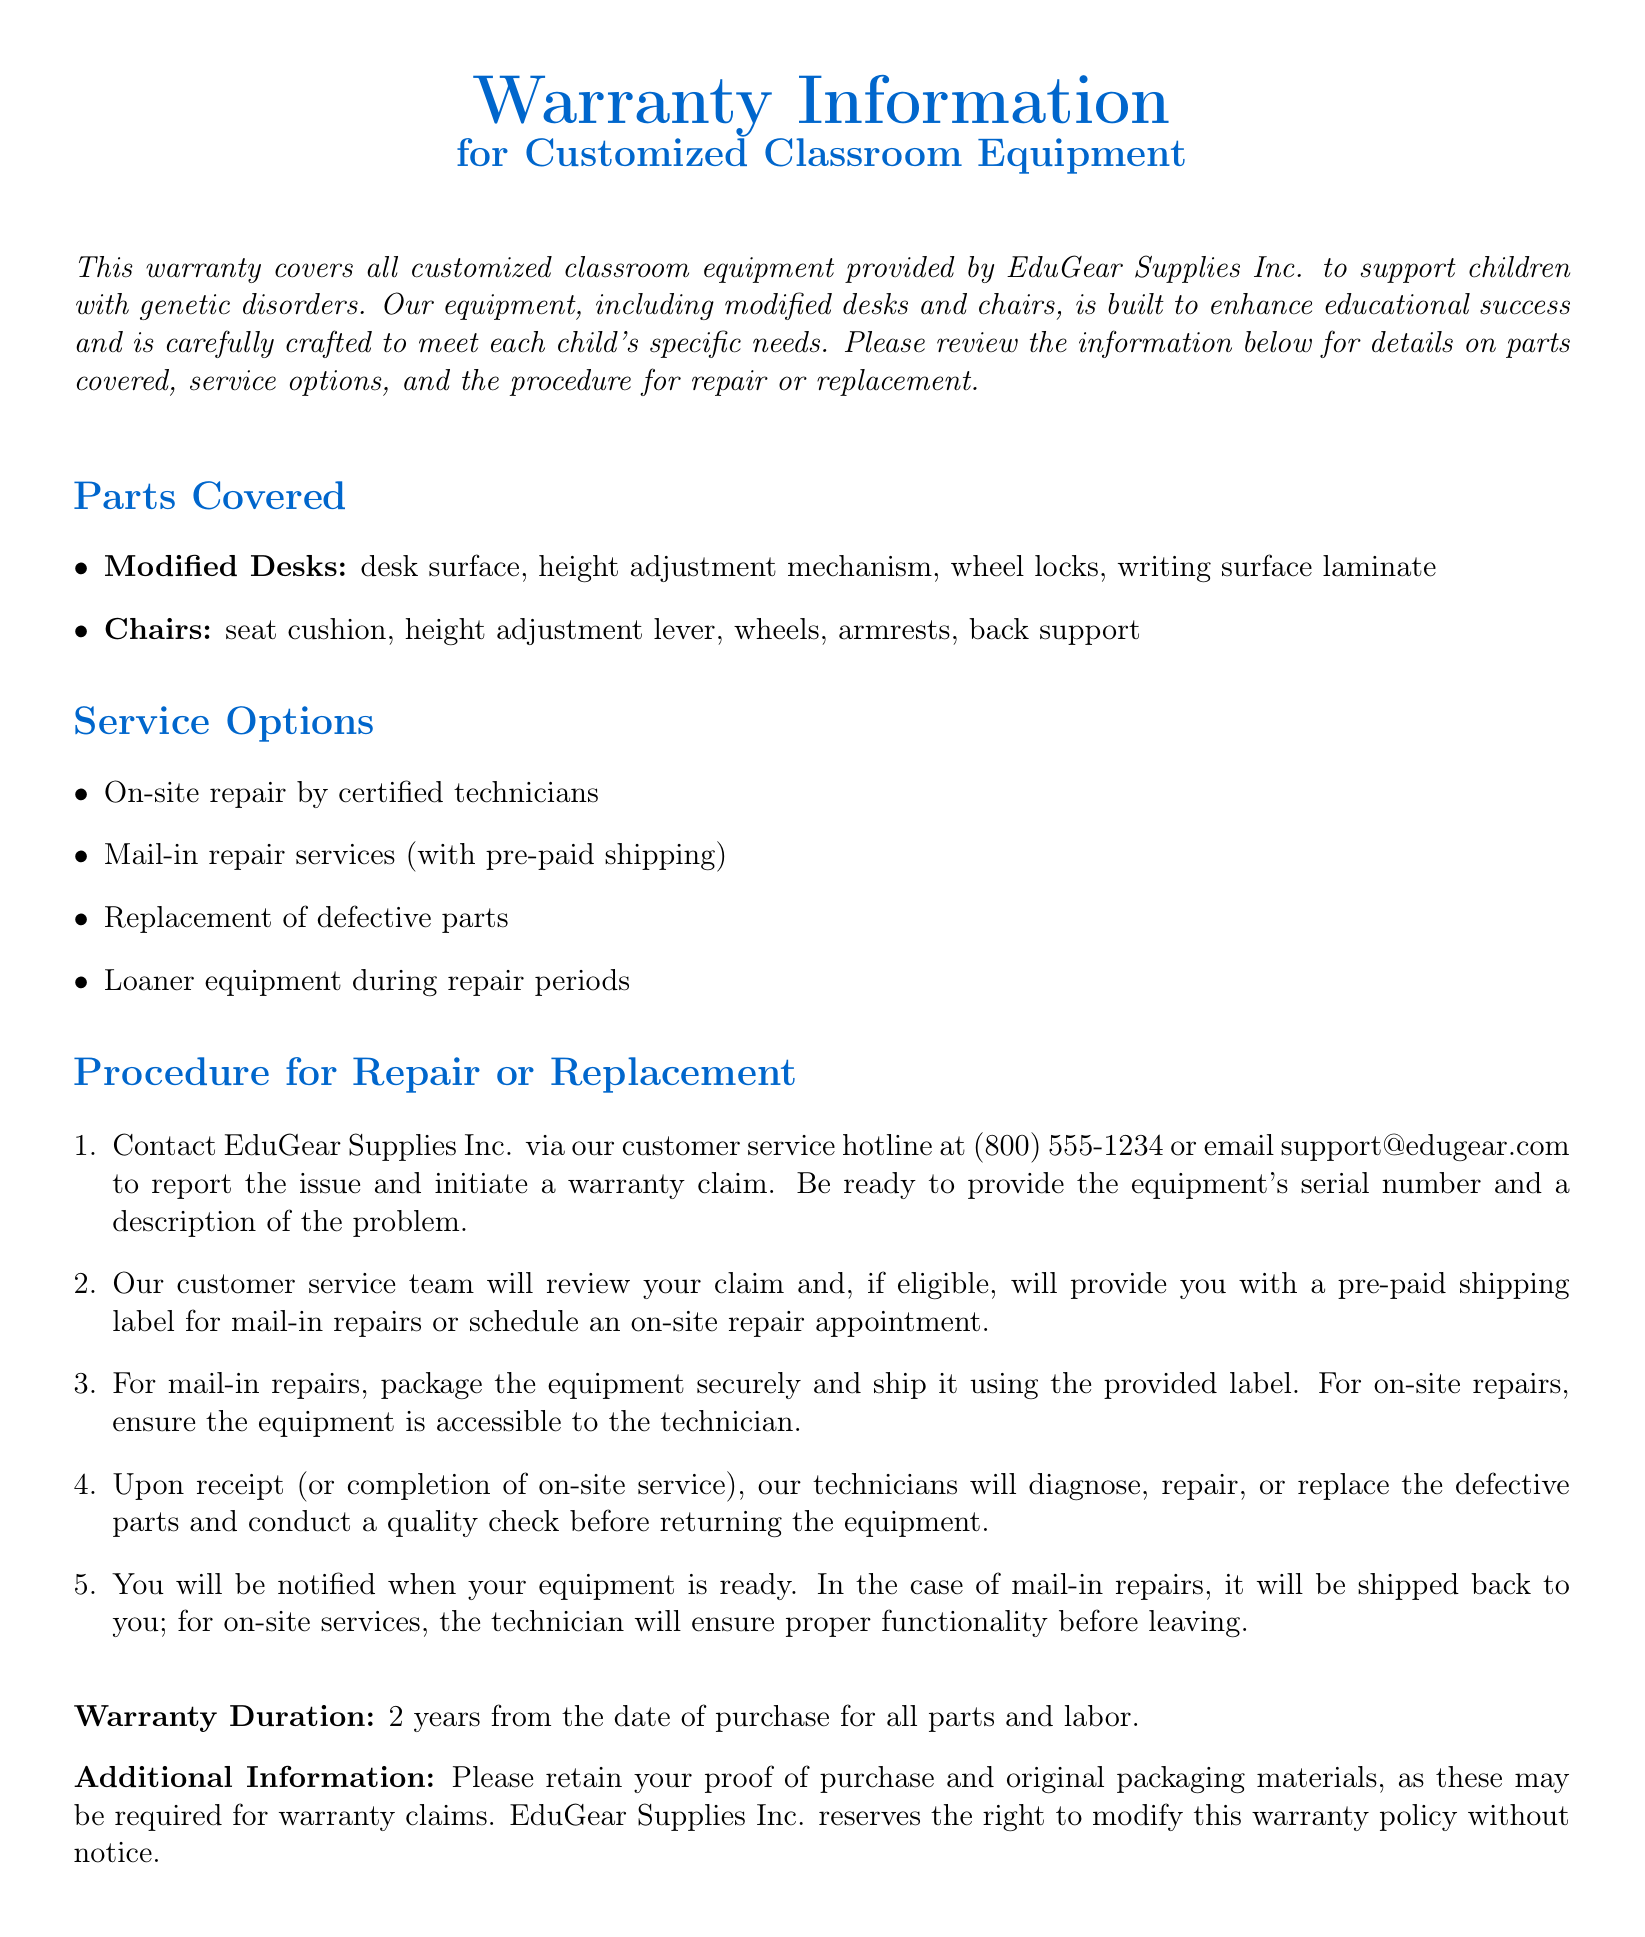What is the warranty duration? The warranty duration is specified in the document, which states it lasts for 2 years from the date of purchase.
Answer: 2 years What parts are covered for modified desks? The document lists specific parts that are covered, including desk surface, height adjustment mechanism, wheel locks, and writing surface laminate.
Answer: desk surface, height adjustment mechanism, wheel locks, writing surface laminate What service options are available for repairs? The document outlines several service options, including on-site repair, mail-in repair services, replacement of defective parts, and loaner equipment during repairs.
Answer: On-site repair, mail-in repair services, replacement of defective parts, loaner equipment What is required to initiate a warranty claim? To initiate a claim, the document states that you should contact EduGear Supplies Inc. and be ready to provide the equipment's serial number and a description of the problem.
Answer: serial number and description of the problem How can customers contact EduGear Supplies Inc.? The document provides specific contact methods for the company, including a customer service hotline and an email address.
Answer: (800) 555-1234 or support@edugear.com Which equipment is covered under this warranty? The document specifies that the warranty coverage is for customized classroom equipment provided by EduGear Supplies Inc., specifically mentioning modified desks and chairs.
Answer: Customized classroom equipment, modified desks, chairs What happens after the claim is reviewed? According to the document, after reviewing the claim, the customer service team will provide either a pre-paid shipping label for mail-in repairs or schedule an on-site repair appointment.
Answer: pre-paid shipping label or schedule an on-site repair appointment Is proof of purchase required for warranty claims? The document mentions that retaining proof of purchase is important and may be required for warranty claims.
Answer: Yes 